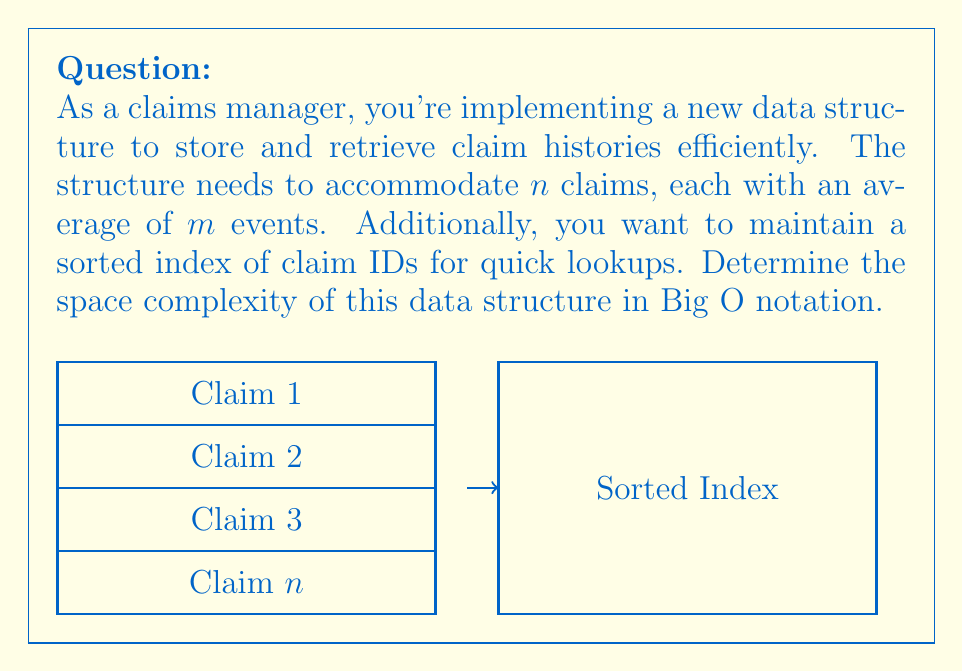Provide a solution to this math problem. Let's break down the space complexity analysis step-by-step:

1. Storing claim events:
   - There are $n$ claims.
   - Each claim has an average of $m$ events.
   - Space required for claim events: $O(n \cdot m)$

2. Sorted index of claim IDs:
   - We need to store $n$ claim IDs in a sorted structure.
   - A balanced binary search tree or similar structure would require $O(n)$ space.

3. Total space complexity:
   - Combining the space for claim events and the sorted index:
     $O(n \cdot m) + O(n)$

4. Simplifying:
   - Since $O(n)$ is dominated by $O(n \cdot m)$ when $m > 1$, we can simplify to:
     $O(n \cdot m)$

Therefore, the overall space complexity of the data structure is $O(n \cdot m)$, where $n$ is the number of claims and $m$ is the average number of events per claim.
Answer: $O(n \cdot m)$ 